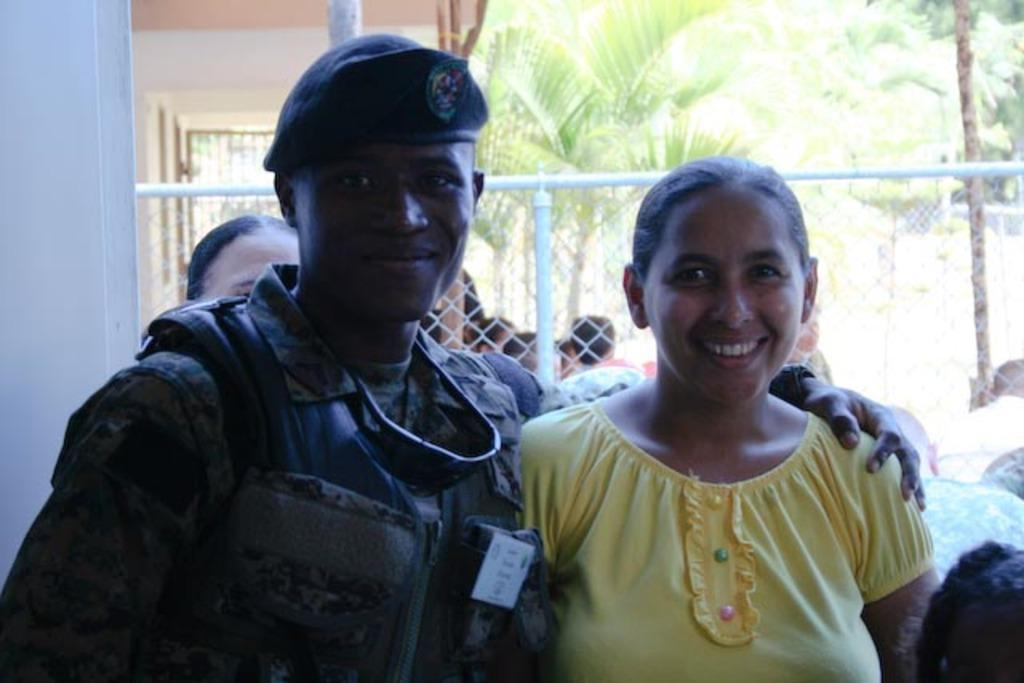How many people are in the image? There are two people, a man and a woman, in the image. What are they doing in the image? They are posing for a camera and smiling. What can be seen in the background of the image? There is a fence, trees, and a wall in the background of the image. What type of hen can be seen in the image? There is no hen present in the image. What is the man rubbing on the woman's arm in the image? There is no indication in the image that the man is rubbing anything on the woman's arm. 